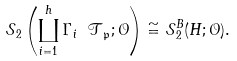Convert formula to latex. <formula><loc_0><loc_0><loc_500><loc_500>\mathcal { S } _ { 2 } \left ( \coprod _ { i = 1 } ^ { h } \Gamma _ { i } \ \mathcal { T } _ { \mathfrak { p } } ; \mathcal { O } \right ) & \cong \mathcal { S } _ { 2 } ^ { B } ( H ; \mathcal { O } ) .</formula> 